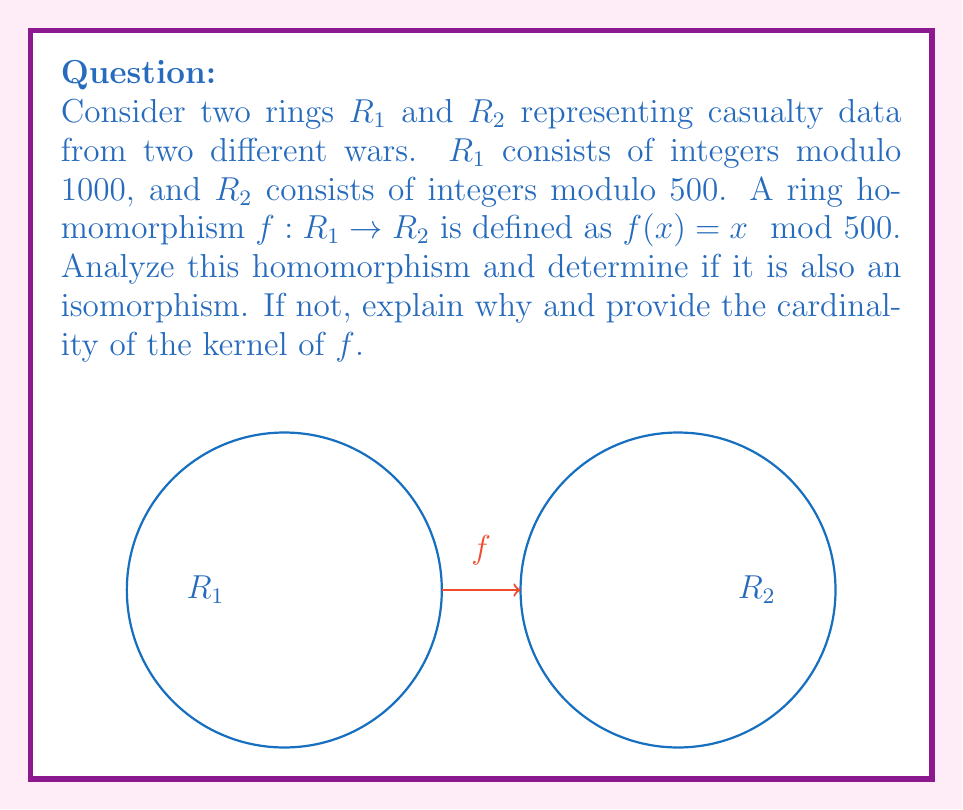Can you solve this math problem? Let's analyze this step-by-step:

1) First, we need to verify if $f$ is indeed a ring homomorphism:
   - $f(x + y) = (x + y) \mod 500 = (x \mod 500 + y \mod 500) \mod 500 = f(x) + f(y)$
   - $f(xy) = (xy) \mod 500 = (x \mod 500)(y \mod 500) \mod 500 = f(x)f(y)$
   - $f(1) = 1 \mod 500 = 1$
   Therefore, $f$ is a ring homomorphism.

2) For $f$ to be an isomorphism, it must be both injective (one-to-one) and surjective (onto).

3) Let's check if $f$ is injective:
   - $\ker(f) = \{x \in R_1 | f(x) = 0\}$
   - This means $x \mod 500 = 0$
   - In $R_1$, this is true for $0, 500$
   - Since $\ker(f) \neq \{0\}$, $f$ is not injective

4) Since $f$ is not injective, it cannot be an isomorphism.

5) To find the cardinality of $\ker(f)$:
   - $|\ker(f)| = |R_1| / |R_2| = 1000 / 500 = 2$
Answer: $f$ is not an isomorphism; $|\ker(f)| = 2$ 